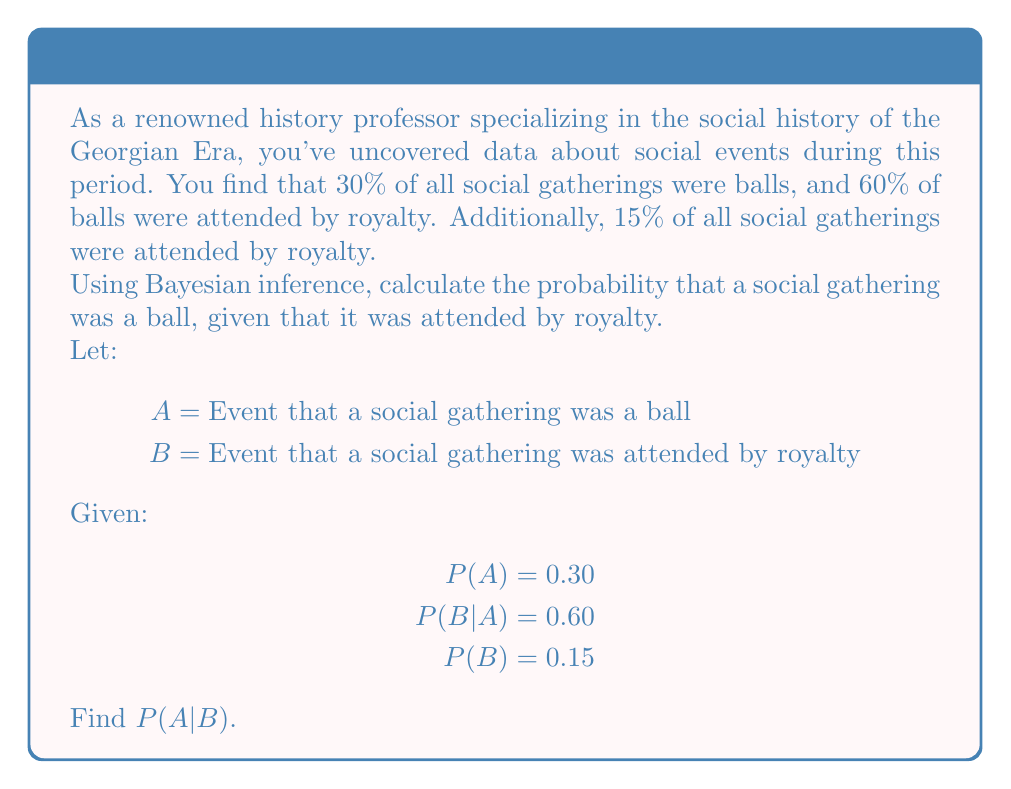Show me your answer to this math problem. To solve this problem using Bayesian inference, we'll use Bayes' theorem:

$$P(A|B) = \frac{P(B|A) \cdot P(A)}{P(B)}$$

We have all the necessary information to plug into this formula:

1. $P(B|A) = 0.60$ (probability of royalty attending, given that it's a ball)
2. $P(A) = 0.30$ (probability of a social gathering being a ball)
3. $P(B) = 0.15$ (probability of royalty attending any social gathering)

Let's substitute these values into Bayes' theorem:

$$P(A|B) = \frac{0.60 \cdot 0.30}{0.15}$$

Now, let's calculate:

$$P(A|B) = \frac{0.18}{0.15} = 1.2$$

Therefore, the probability that a social gathering was a ball, given that it was attended by royalty, is 1.2 or 120%.

This result might seem counterintuitive at first, as probabilities typically range from 0 to 1 (or 0% to 100%). However, in this case, the result suggests that our initial assumptions or data might be inconsistent or contain an error. 

In a real-world scenario, we would need to re-examine our data and assumptions to ensure they are logically consistent and accurately represent the historical context of the Georgian Era.
Answer: $P(A|B) = 1.2$ (or 120%), indicating potential inconsistencies in the given data or assumptions. 